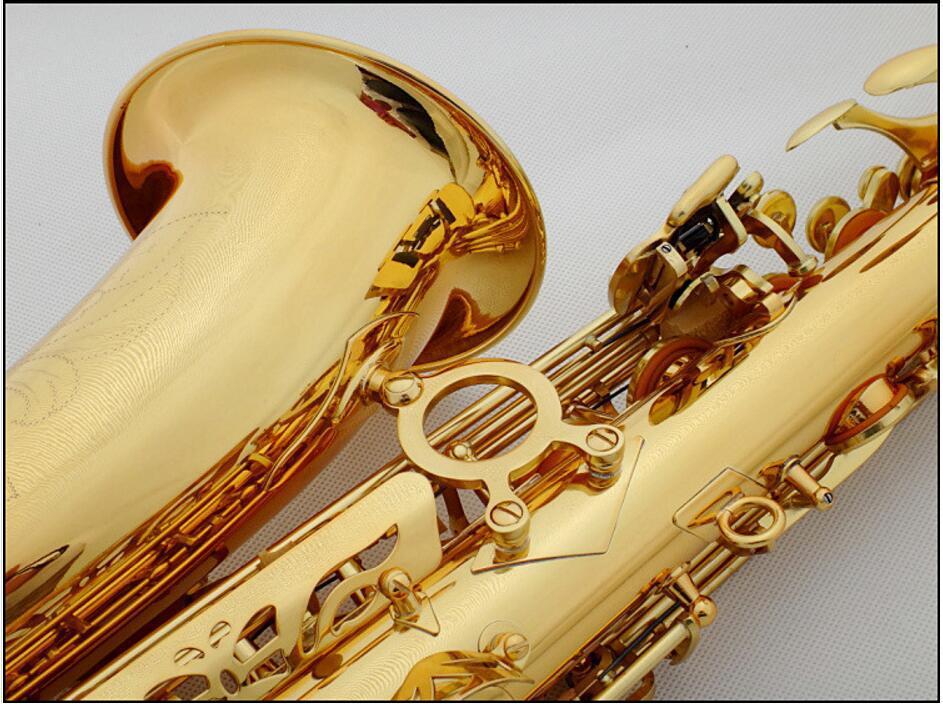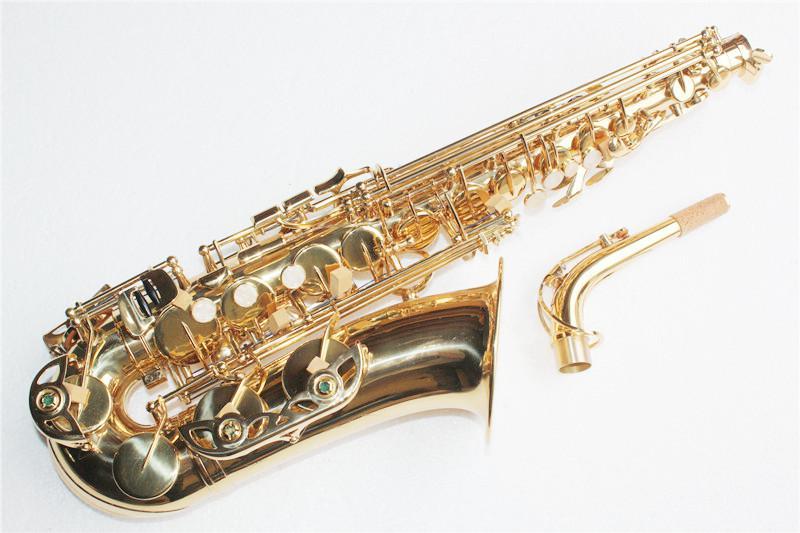The first image is the image on the left, the second image is the image on the right. For the images shown, is this caption "A mouthpiece with a black tip is next to a gold-colored saxophone in one image." true? Answer yes or no. No. The first image is the image on the left, the second image is the image on the right. Examine the images to the left and right. Is the description "At least one of the images shows a booklet next to the instrument." accurate? Answer yes or no. No. 